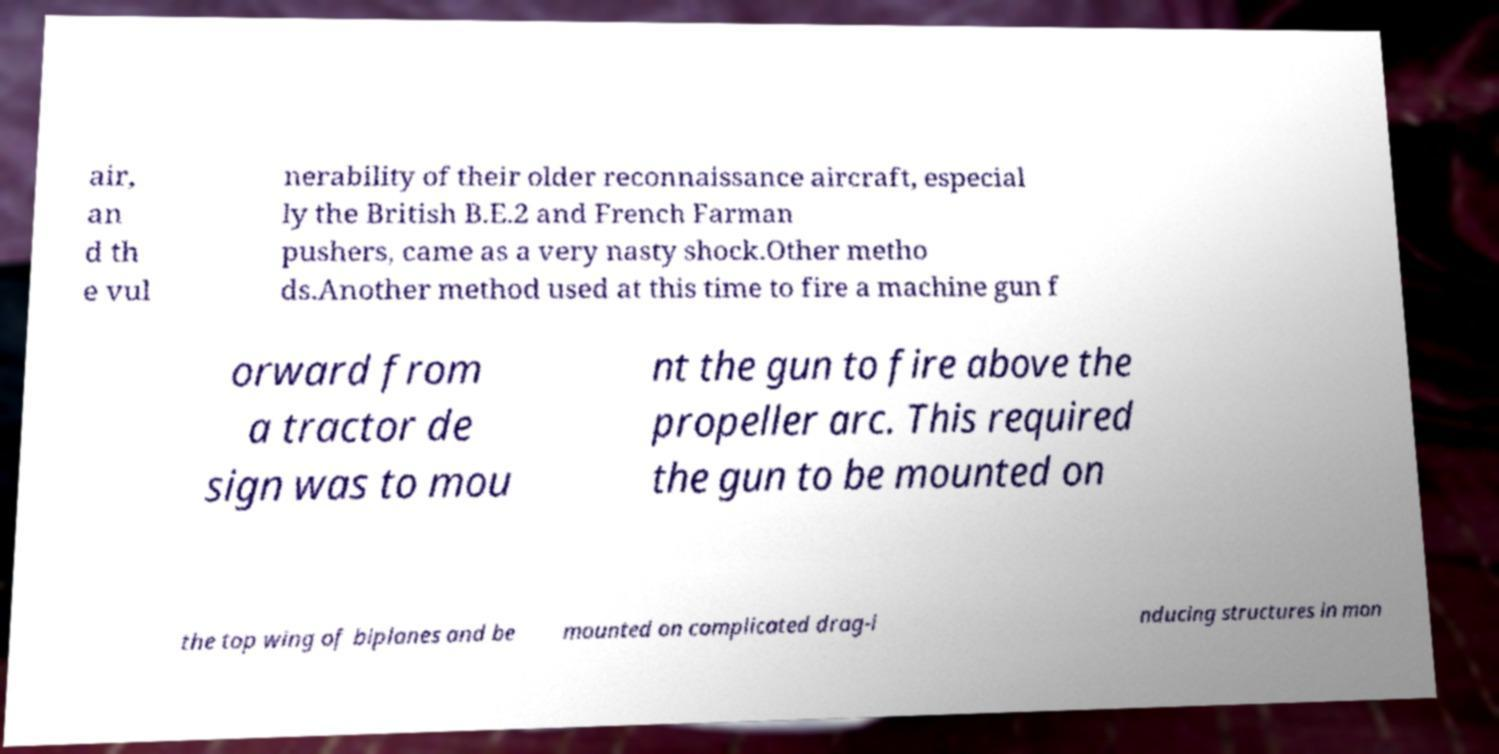Please read and relay the text visible in this image. What does it say? air, an d th e vul nerability of their older reconnaissance aircraft, especial ly the British B.E.2 and French Farman pushers, came as a very nasty shock.Other metho ds.Another method used at this time to fire a machine gun f orward from a tractor de sign was to mou nt the gun to fire above the propeller arc. This required the gun to be mounted on the top wing of biplanes and be mounted on complicated drag-i nducing structures in mon 